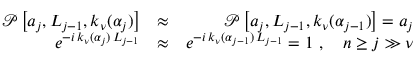<formula> <loc_0><loc_0><loc_500><loc_500>\begin{array} { r l r } { \mathcal { P } \left [ a _ { j } , L _ { j - 1 } , k _ { \nu } ( \alpha _ { j } ) \right ] } & { \approx } & { \mathcal { P } \left [ a _ { j } , L _ { j - 1 } , k _ { \nu } ( \alpha _ { j - 1 } ) \right ] = a _ { j } } \\ { e ^ { - i \, k _ { \nu } ( \alpha _ { j } ) \, L _ { j - 1 } } } & { \approx } & { e ^ { - i \, k _ { \nu } ( \alpha _ { j - 1 } ) \, L _ { j - 1 } } = 1 \ , \quad n \geq j \gg \nu } \end{array}</formula> 